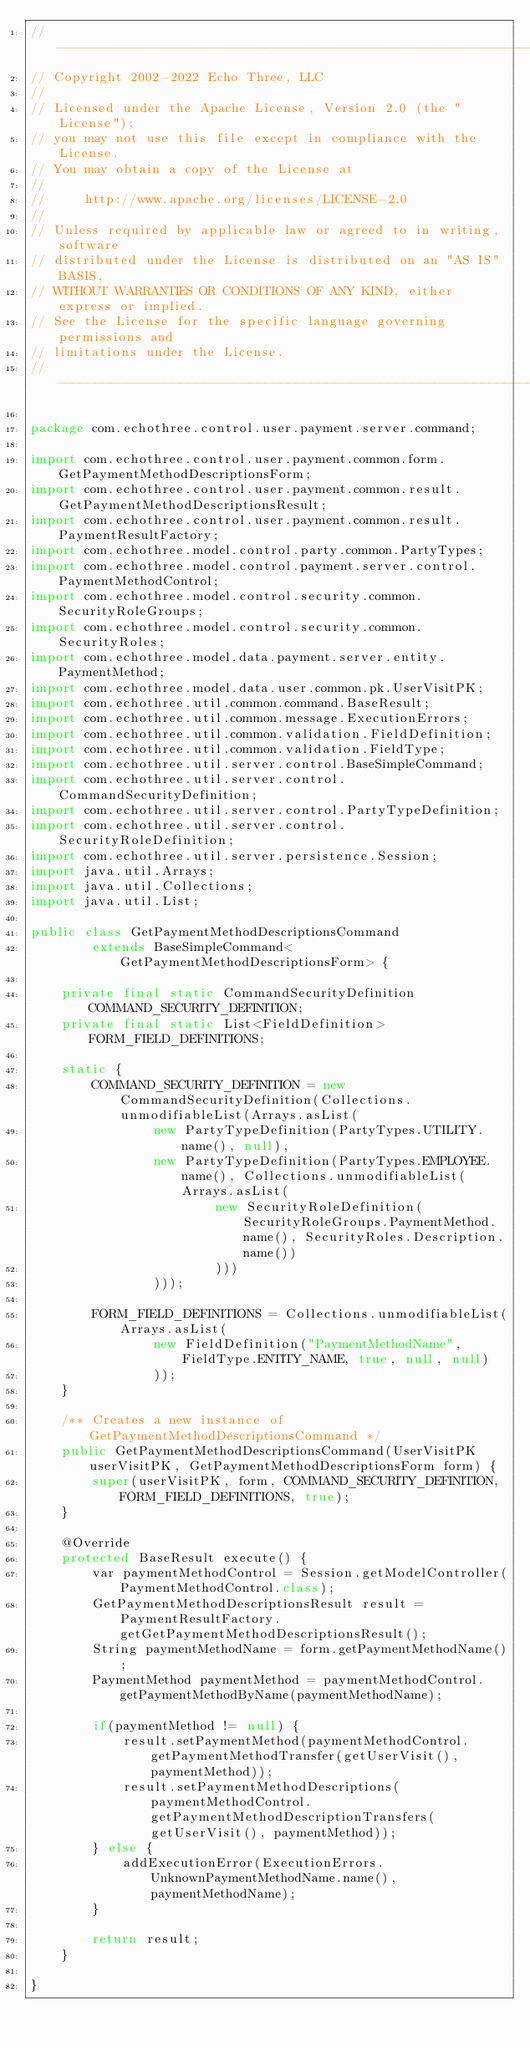Convert code to text. <code><loc_0><loc_0><loc_500><loc_500><_Java_>// --------------------------------------------------------------------------------
// Copyright 2002-2022 Echo Three, LLC
//
// Licensed under the Apache License, Version 2.0 (the "License");
// you may not use this file except in compliance with the License.
// You may obtain a copy of the License at
//
//     http://www.apache.org/licenses/LICENSE-2.0
//
// Unless required by applicable law or agreed to in writing, software
// distributed under the License is distributed on an "AS IS" BASIS,
// WITHOUT WARRANTIES OR CONDITIONS OF ANY KIND, either express or implied.
// See the License for the specific language governing permissions and
// limitations under the License.
// --------------------------------------------------------------------------------

package com.echothree.control.user.payment.server.command;

import com.echothree.control.user.payment.common.form.GetPaymentMethodDescriptionsForm;
import com.echothree.control.user.payment.common.result.GetPaymentMethodDescriptionsResult;
import com.echothree.control.user.payment.common.result.PaymentResultFactory;
import com.echothree.model.control.party.common.PartyTypes;
import com.echothree.model.control.payment.server.control.PaymentMethodControl;
import com.echothree.model.control.security.common.SecurityRoleGroups;
import com.echothree.model.control.security.common.SecurityRoles;
import com.echothree.model.data.payment.server.entity.PaymentMethod;
import com.echothree.model.data.user.common.pk.UserVisitPK;
import com.echothree.util.common.command.BaseResult;
import com.echothree.util.common.message.ExecutionErrors;
import com.echothree.util.common.validation.FieldDefinition;
import com.echothree.util.common.validation.FieldType;
import com.echothree.util.server.control.BaseSimpleCommand;
import com.echothree.util.server.control.CommandSecurityDefinition;
import com.echothree.util.server.control.PartyTypeDefinition;
import com.echothree.util.server.control.SecurityRoleDefinition;
import com.echothree.util.server.persistence.Session;
import java.util.Arrays;
import java.util.Collections;
import java.util.List;

public class GetPaymentMethodDescriptionsCommand
        extends BaseSimpleCommand<GetPaymentMethodDescriptionsForm> {
    
    private final static CommandSecurityDefinition COMMAND_SECURITY_DEFINITION;
    private final static List<FieldDefinition> FORM_FIELD_DEFINITIONS;
    
    static {
        COMMAND_SECURITY_DEFINITION = new CommandSecurityDefinition(Collections.unmodifiableList(Arrays.asList(
                new PartyTypeDefinition(PartyTypes.UTILITY.name(), null),
                new PartyTypeDefinition(PartyTypes.EMPLOYEE.name(), Collections.unmodifiableList(Arrays.asList(
                        new SecurityRoleDefinition(SecurityRoleGroups.PaymentMethod.name(), SecurityRoles.Description.name())
                        )))
                )));

        FORM_FIELD_DEFINITIONS = Collections.unmodifiableList(Arrays.asList(
                new FieldDefinition("PaymentMethodName", FieldType.ENTITY_NAME, true, null, null)
                ));
    }
    
    /** Creates a new instance of GetPaymentMethodDescriptionsCommand */
    public GetPaymentMethodDescriptionsCommand(UserVisitPK userVisitPK, GetPaymentMethodDescriptionsForm form) {
        super(userVisitPK, form, COMMAND_SECURITY_DEFINITION, FORM_FIELD_DEFINITIONS, true);
    }
    
    @Override
    protected BaseResult execute() {
        var paymentMethodControl = Session.getModelController(PaymentMethodControl.class);
        GetPaymentMethodDescriptionsResult result = PaymentResultFactory.getGetPaymentMethodDescriptionsResult();
        String paymentMethodName = form.getPaymentMethodName();
        PaymentMethod paymentMethod = paymentMethodControl.getPaymentMethodByName(paymentMethodName);
        
        if(paymentMethod != null) {
            result.setPaymentMethod(paymentMethodControl.getPaymentMethodTransfer(getUserVisit(), paymentMethod));
            result.setPaymentMethodDescriptions(paymentMethodControl.getPaymentMethodDescriptionTransfers(getUserVisit(), paymentMethod));
        } else {
            addExecutionError(ExecutionErrors.UnknownPaymentMethodName.name(), paymentMethodName);
        }
        
        return result;
    }
    
}
</code> 